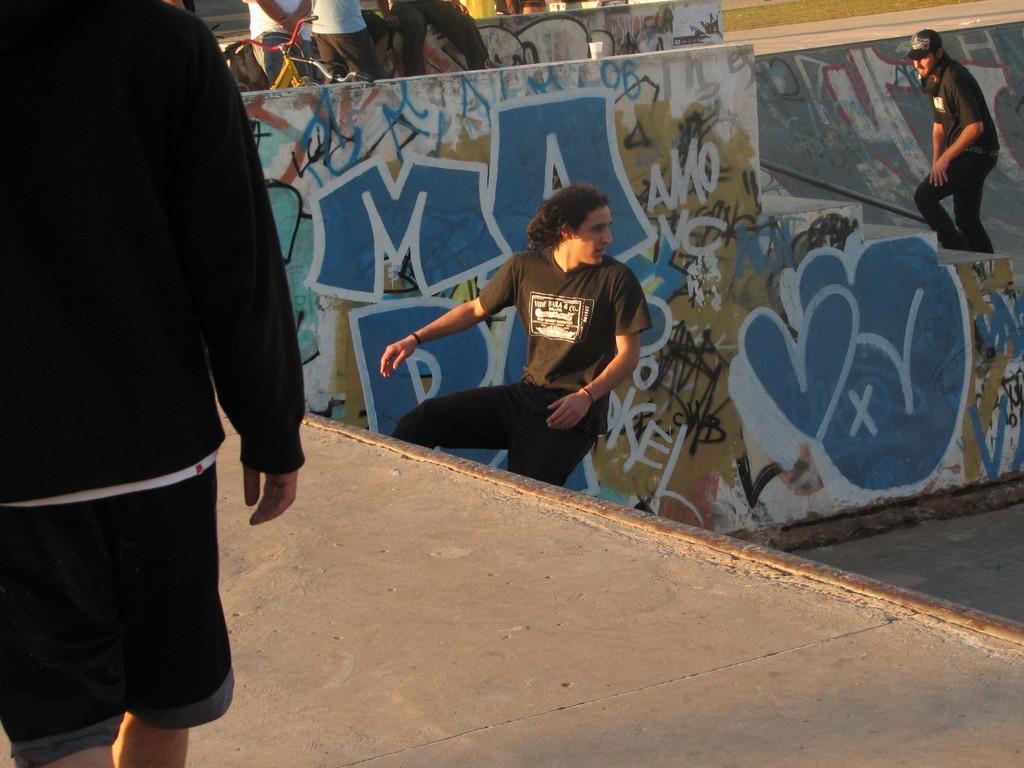Please provide a concise description of this image. Here in this picture in the front we can see a person standing on the ground and in the middle we can see a person on a skating floor and beside him we can see some text painted on the wall and on the right side we can see a person walking on the steps and in the middle we can see some people standing over the place and we can also see bicycles and cup present and we can see some part of ground is covered with grass. 